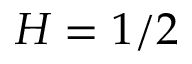Convert formula to latex. <formula><loc_0><loc_0><loc_500><loc_500>H = 1 / 2</formula> 